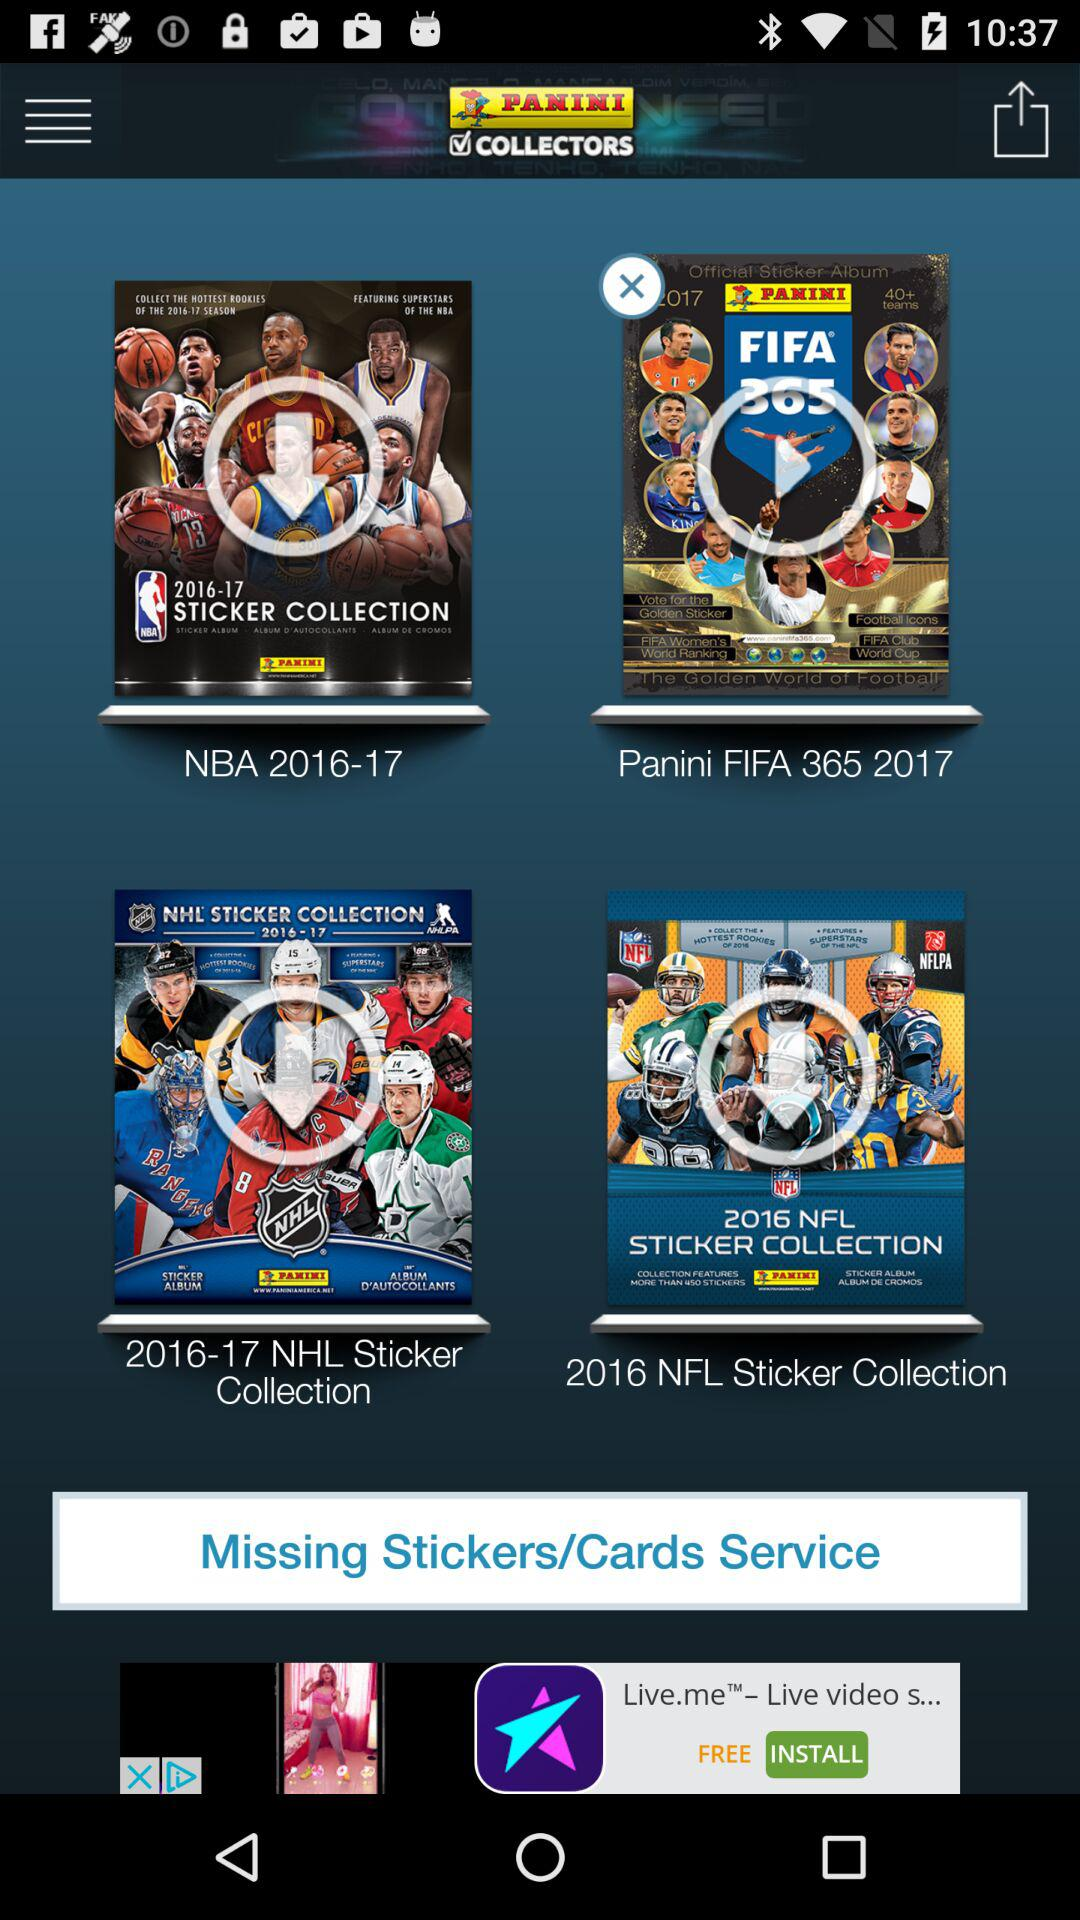What is the application name? The application is "Panini Collectors". 